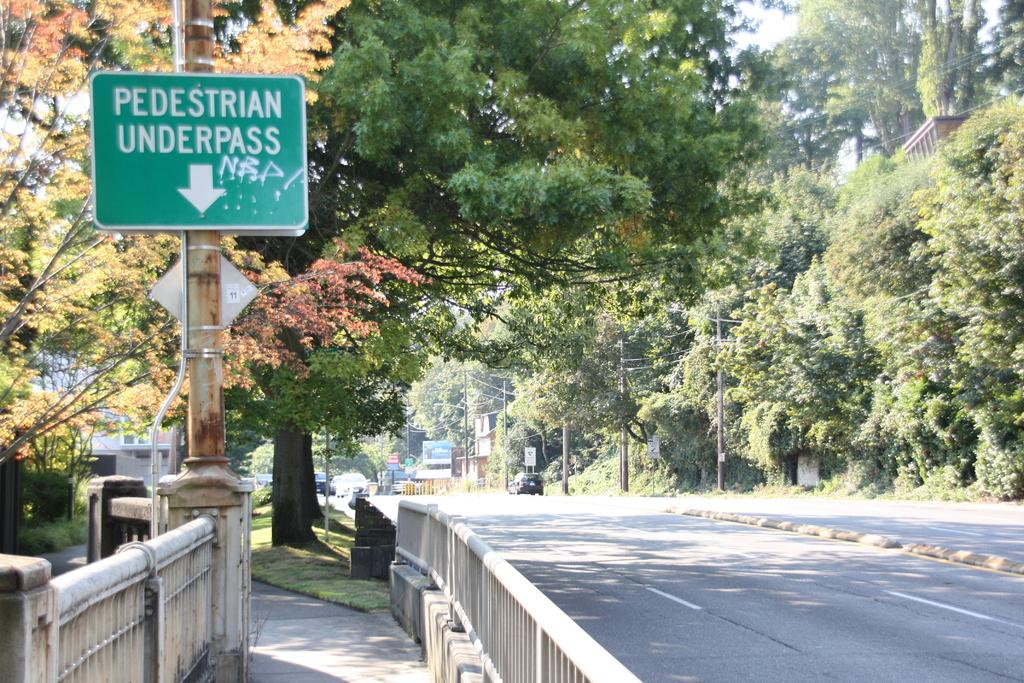What type of surface can be seen in the image? There is a road and a path visible in the image. What type of vegetation is present in the image? There is grass in the image. What structures can be seen in the image? There are fences, poles, name boards, buildings, and a banner visible in the image. What objects are present in the image? There are vehicles, wires, and some objects visible in the image. What can be seen in the background of the image? There are trees visible in the background of the image. Where is the vase located in the image? There is no vase present in the image. What angle is the banner placed at in the image? The angle at which the banner is placed cannot be determined from the image. 